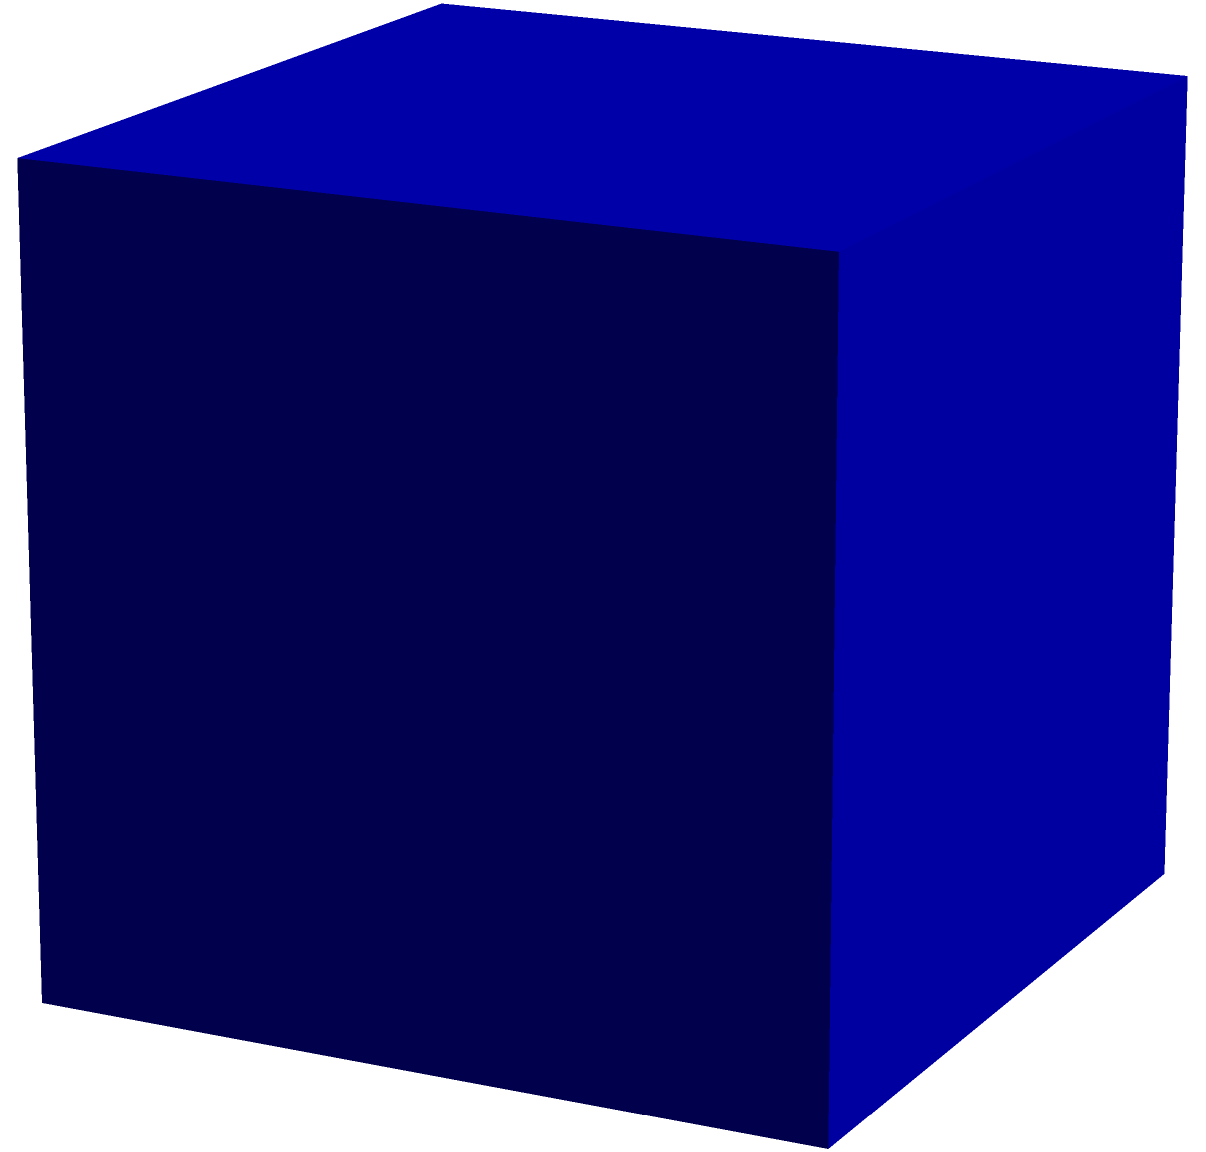In the grand finale of The Voice Kids Portugal, the producers want to use a cube-shaped LED screen as a backdrop. If each side of the cube measures 5 meters, what is the total surface area of the LED screen in square meters? To find the surface area of a cube, we need to follow these steps:

1. Understand that a cube has 6 identical square faces.
2. Calculate the area of one face:
   - Area of one face = $a^2$, where $a$ is the length of one side
   - In this case, $a = 5$ meters
   - Area of one face = $5^2 = 25$ square meters

3. Multiply the area of one face by 6 to get the total surface area:
   - Total surface area = $6 \times 25 = 150$ square meters

Therefore, the total surface area of the LED screen backdrop is 150 square meters.
Answer: $150\text{ m}^2$ 